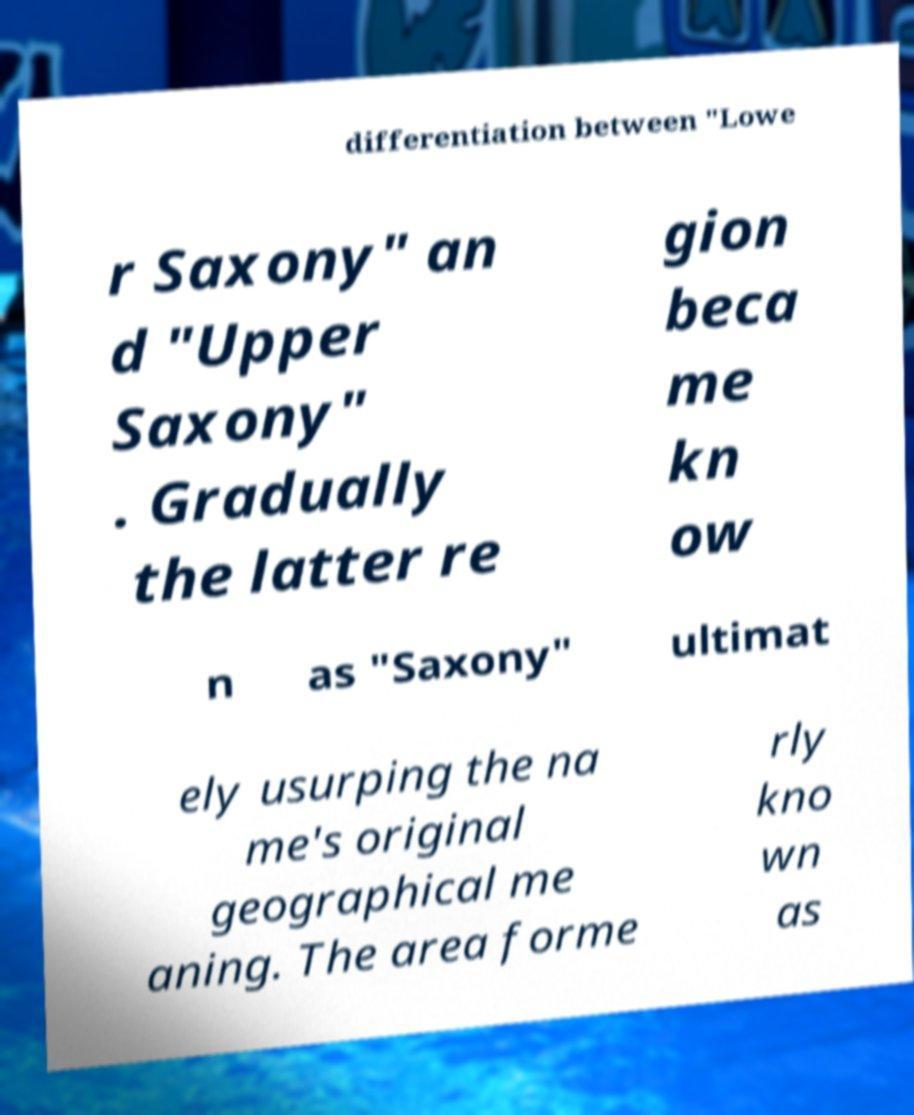Please identify and transcribe the text found in this image. differentiation between "Lowe r Saxony" an d "Upper Saxony" . Gradually the latter re gion beca me kn ow n as "Saxony" ultimat ely usurping the na me's original geographical me aning. The area forme rly kno wn as 